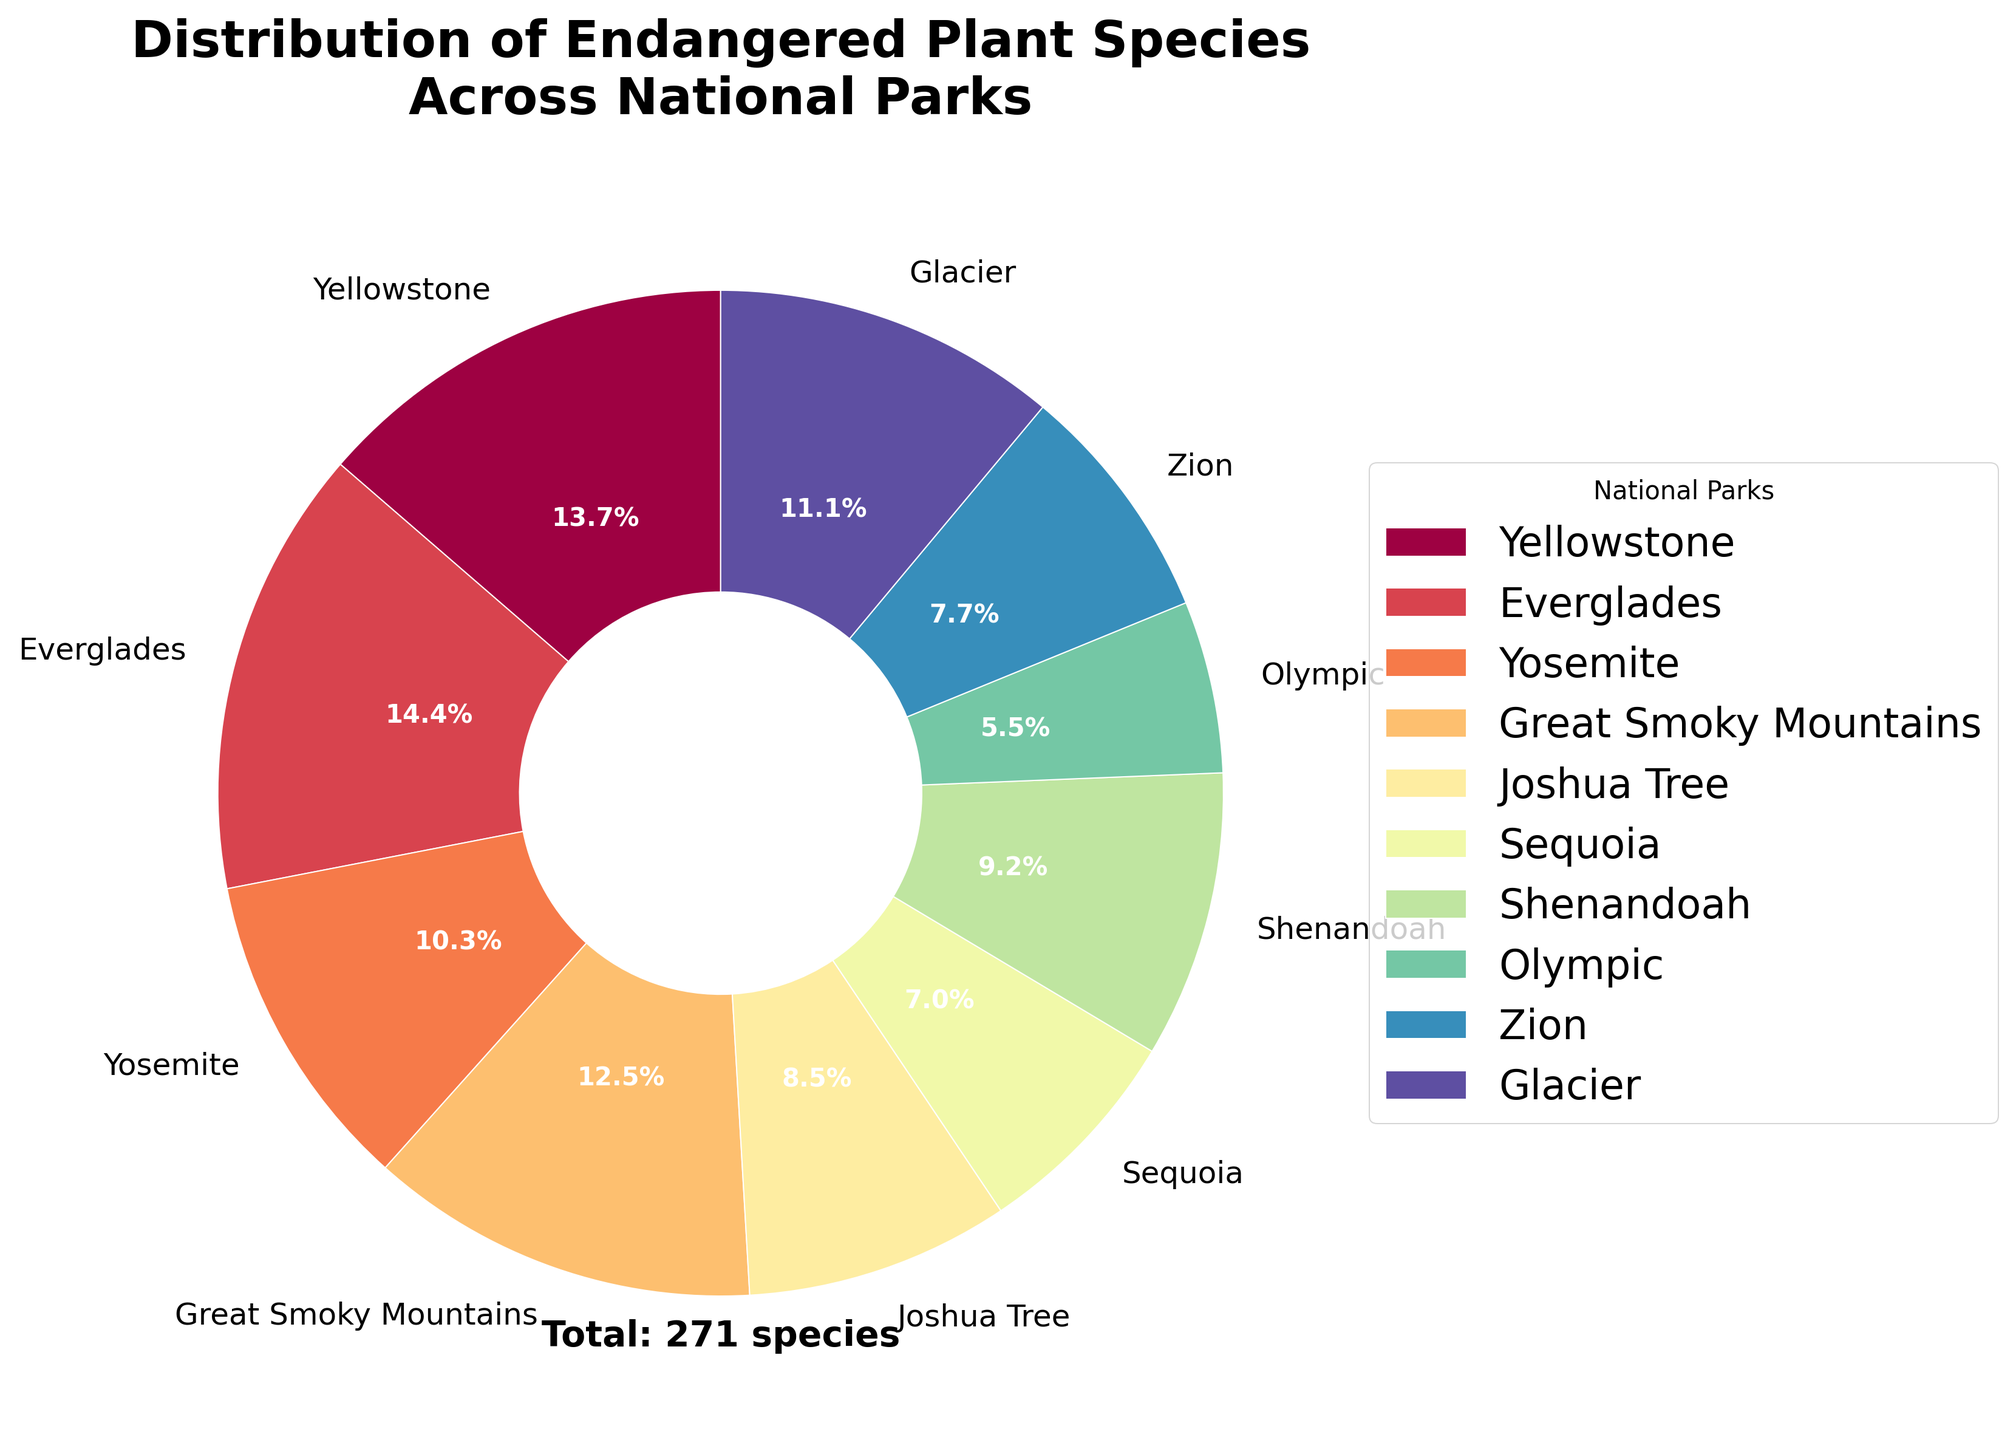What is the total number of endangered plant species across all national parks? Add the number of endangered plant species from each park: 37 (Yellowstone) + 39 (Everglades) + 28 (Yosemite) + 34 (Great Smoky Mountains) + 23 (Joshua Tree) + 19 (Sequoia) + 25 (Shenandoah) + 15 (Olympic) + 21 (Zion) + 30 (Glacier). The total is 271.
Answer: 271 Which national park harbors the most endangered plant species? Look for the park that has the largest wedge percentage in the pie chart. Everglades has the largest sector, representing 39 endangered plant species.
Answer: Everglades What percentage of the total endangered plant species is found in Yellowstone? Divide the number of endangered plant species in Yellowstone (37) by the total number (271) and multiply by 100. (37/271) * 100 ≈ 13.6%.
Answer: 13.6% How many more endangered plant species does Everglades have compared to Olympic? Subtract the number of endangered plant species in Olympic (15) from that in Everglades (39). 39 - 15 = 24.
Answer: 24 Which parks have fewer than 20 endangered plant species? Check the parks with segments in the pie chart representing fewer than 20 species. Sequoia (19) and Olympic (15) both fall below 20.
Answer: Sequoia and Olympic What is the combined percentage of endangered plant species found in Zion and Shenandoah? Add the species from Zion (21) and Shenandoah (25) to get 46. Divide by the total (271) and multiply by 100. (46/271) * 100 ≈ 17%.
Answer: 17% Compare the proportion of endangered plant species between Joshua Tree and Great Smoky Mountains. Which has a higher proportion and by how much? Find the number of species for Joshua Tree (23) and Great Smoky Mountains (34). The difference is 34 - 23. Divide each by the total (271) and multiply by 100 to find their proportions. Joshua Tree: (23/271) * 100 ≈ 8.5%, Great Smoky Mountains: (34/271) * 100 ≈ 12.5%. The difference in proportion is 12.5% - 8.5% = 4%.
Answer: Great Smoky Mountains by 4% Which national park has the smallest wedge in the pie chart and how many endangered plant species does it represent? Identify the park with the smallest wedge size in the pie chart. Olympic has the smallest wedge, representing 15 endangered plant species.
Answer: Olympic, 15 What fraction of the endangered plant species are found in Glacier and Yosemite combined? Add the species from Glacier (30) and Yosemite (28). Combined, it is 58. The fraction is 58/271. Simplified, this is approximately 21/99.
Answer: 58/271 or approximately 21/99 How do the numbers of endangered plant species in Sequoia and Zion compare to the total number of such species in the remaining parks (excluding Sequoia and Zion)? Add the species from Sequoia (19) and Zion (21) to get 40. Subtract these 40 from the total (271) to get the remaining parks, which is 231.
Answer: Sequoia and Zion combined: 40, Remaining parks: 231 